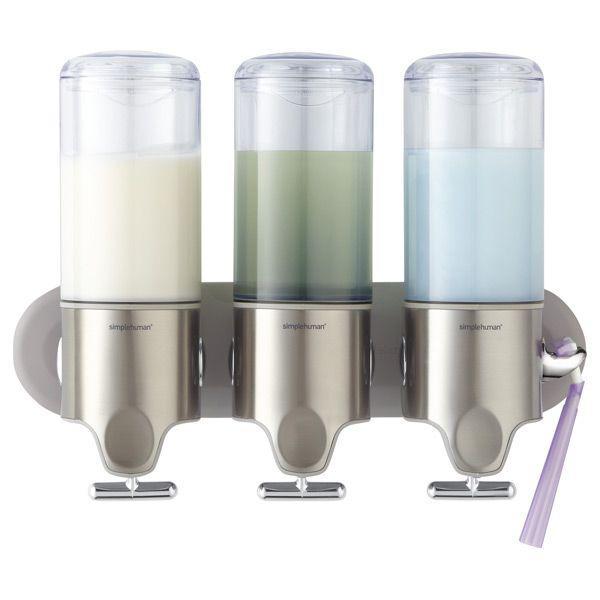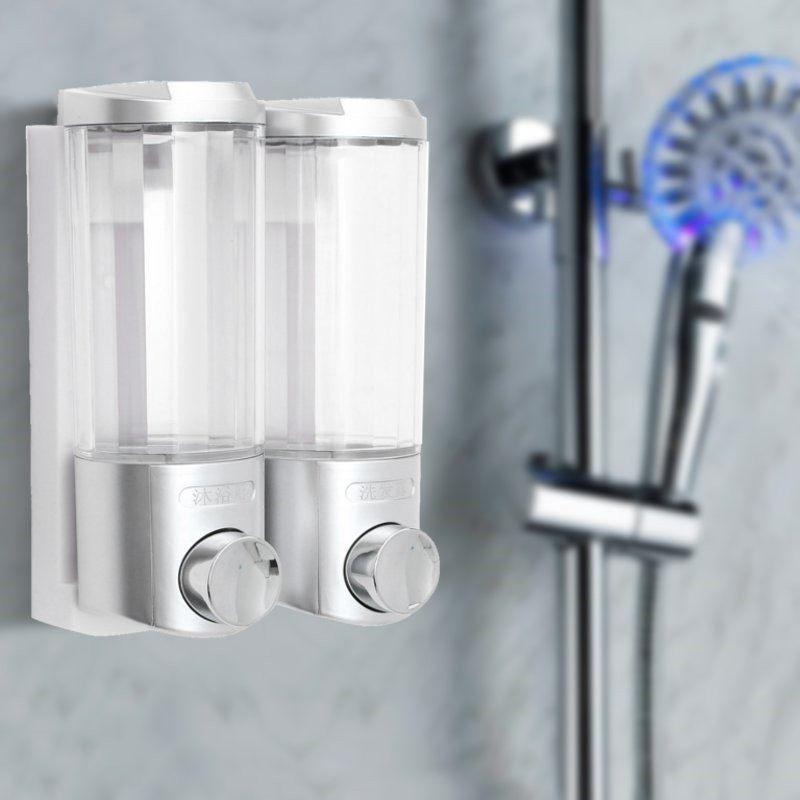The first image is the image on the left, the second image is the image on the right. Examine the images to the left and right. Is the description "There are at least six dispensers." accurate? Answer yes or no. No. The first image is the image on the left, the second image is the image on the right. Evaluate the accuracy of this statement regarding the images: "In a group of three shower soap dispensers, one contains green liquid soap.". Is it true? Answer yes or no. Yes. 